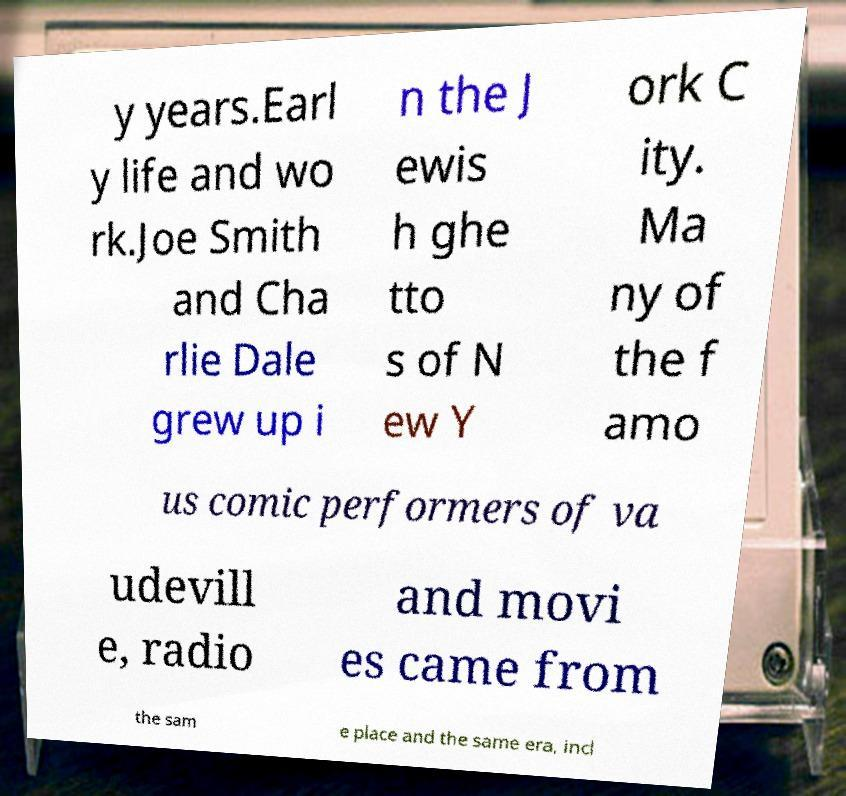Can you accurately transcribe the text from the provided image for me? y years.Earl y life and wo rk.Joe Smith and Cha rlie Dale grew up i n the J ewis h ghe tto s of N ew Y ork C ity. Ma ny of the f amo us comic performers of va udevill e, radio and movi es came from the sam e place and the same era, incl 